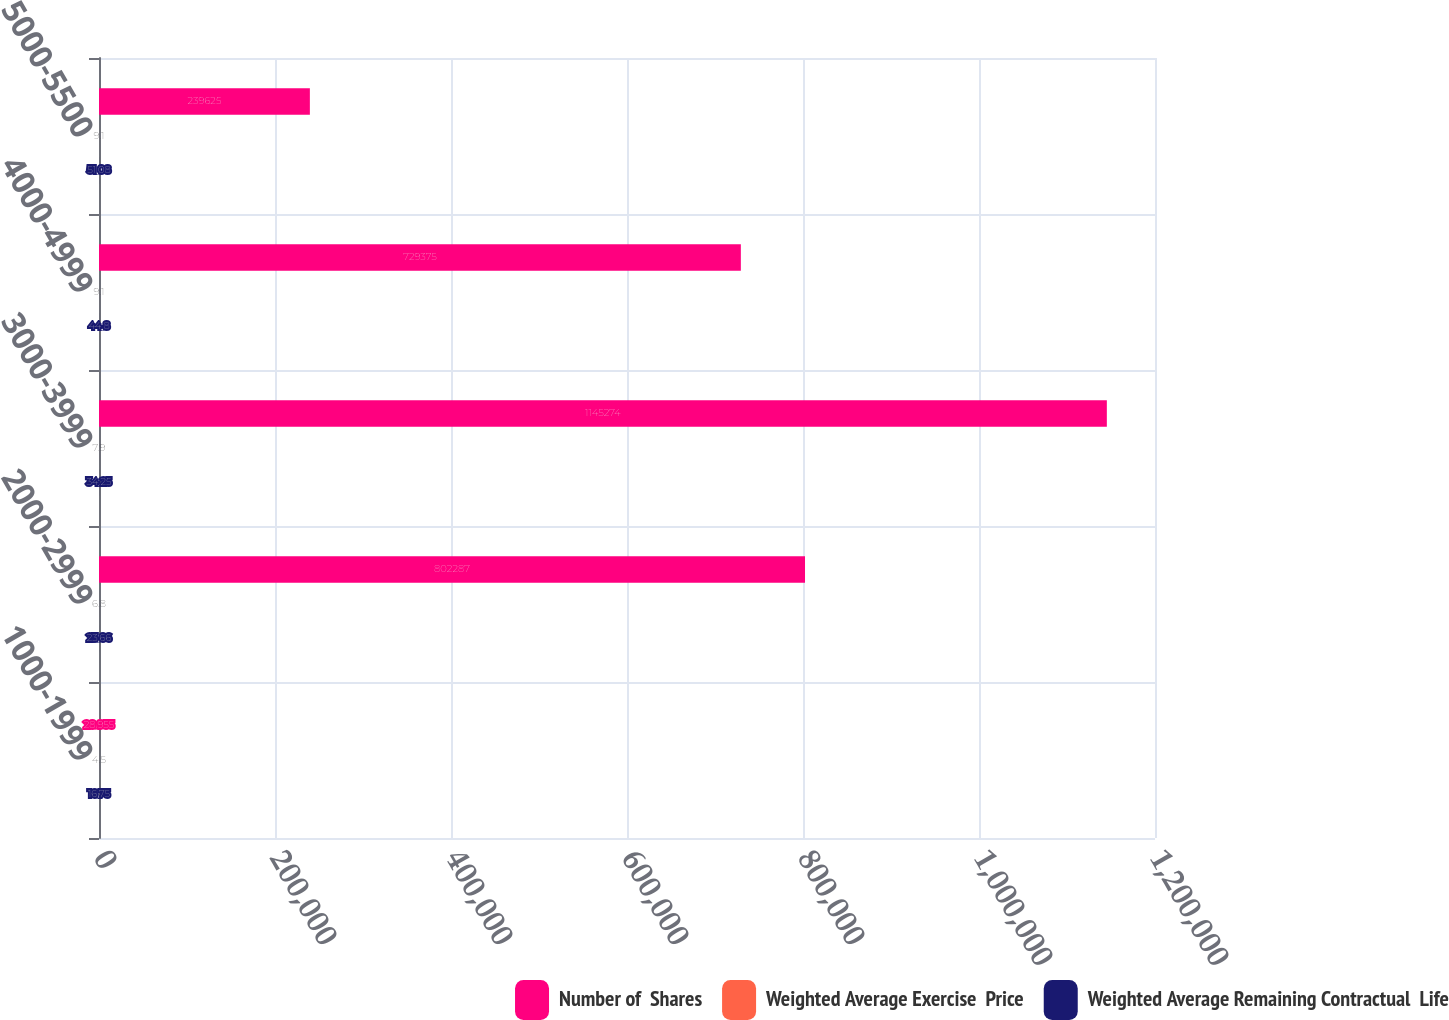Convert chart. <chart><loc_0><loc_0><loc_500><loc_500><stacked_bar_chart><ecel><fcel>1000-1999<fcel>2000-2999<fcel>3000-3999<fcel>4000-4999<fcel>5000-5500<nl><fcel>Number of  Shares<fcel>28.955<fcel>802287<fcel>1.14527e+06<fcel>729375<fcel>239625<nl><fcel>Weighted Average Exercise  Price<fcel>4.5<fcel>6.8<fcel>7.9<fcel>9.1<fcel>9.1<nl><fcel>Weighted Average Remaining Contractual  Life<fcel>16.75<fcel>23.66<fcel>34.25<fcel>44.8<fcel>51.08<nl></chart> 